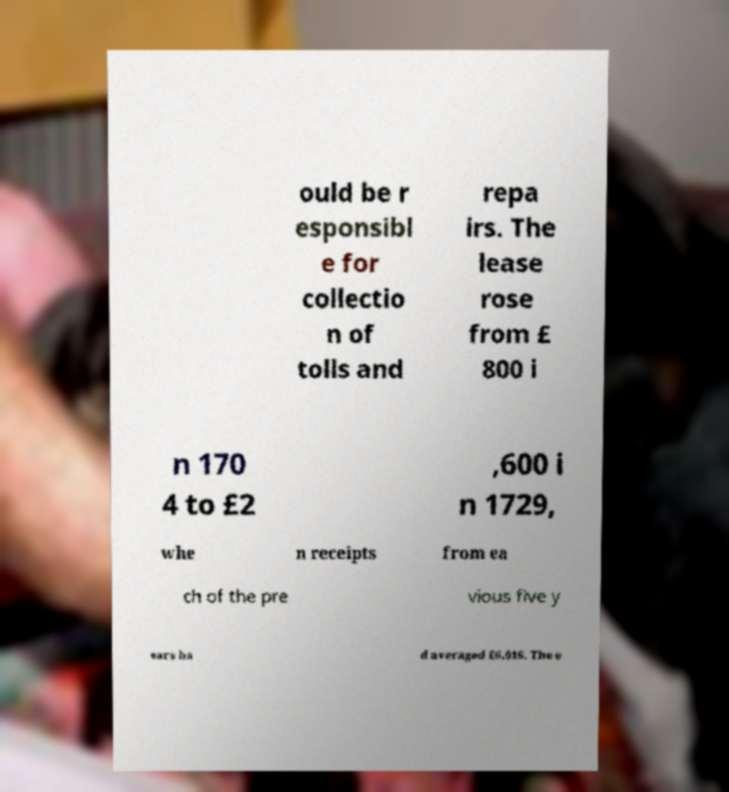Can you read and provide the text displayed in the image?This photo seems to have some interesting text. Can you extract and type it out for me? ould be r esponsibl e for collectio n of tolls and repa irs. The lease rose from £ 800 i n 170 4 to £2 ,600 i n 1729, whe n receipts from ea ch of the pre vious five y ears ha d averaged £6,016. The e 